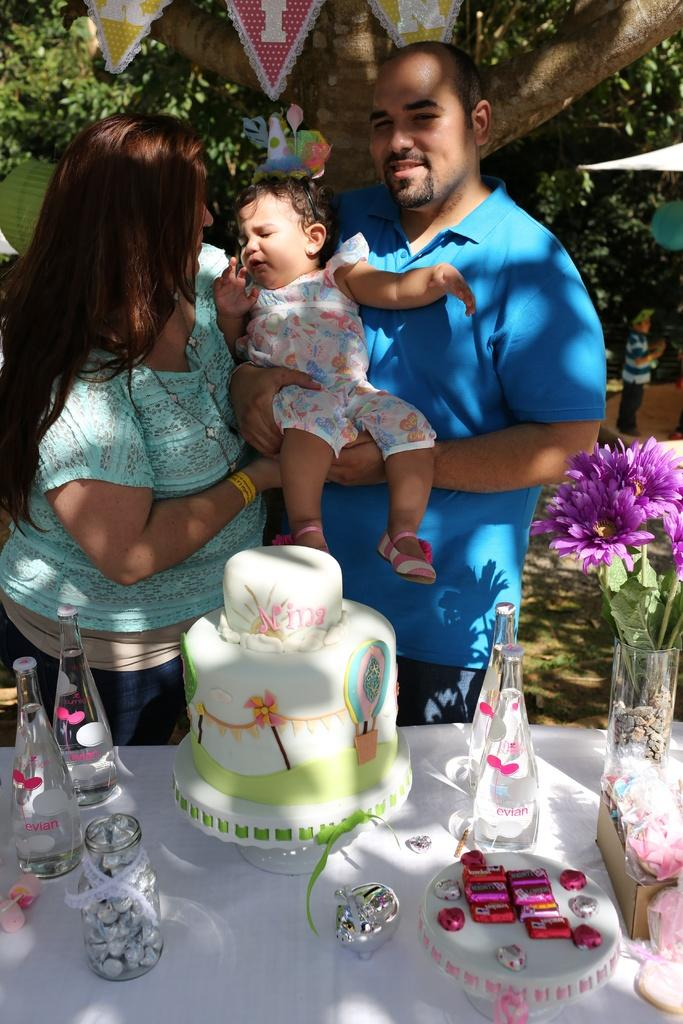Who is present in the image? There is a woman and a man in the image. What are the woman and man doing in the image? The woman and man are holding a baby in the image. What is on the table in the image? There is a cake and bottles on the table in the image. Can you describe the table in the image? There is a table in the image. What color are the eyes of the orange in the image? There is no orange present in the image, and therefore no eyes to describe. 